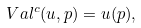Convert formula to latex. <formula><loc_0><loc_0><loc_500><loc_500>\ V a l ^ { c } ( u , p ) = u ( p ) ,</formula> 